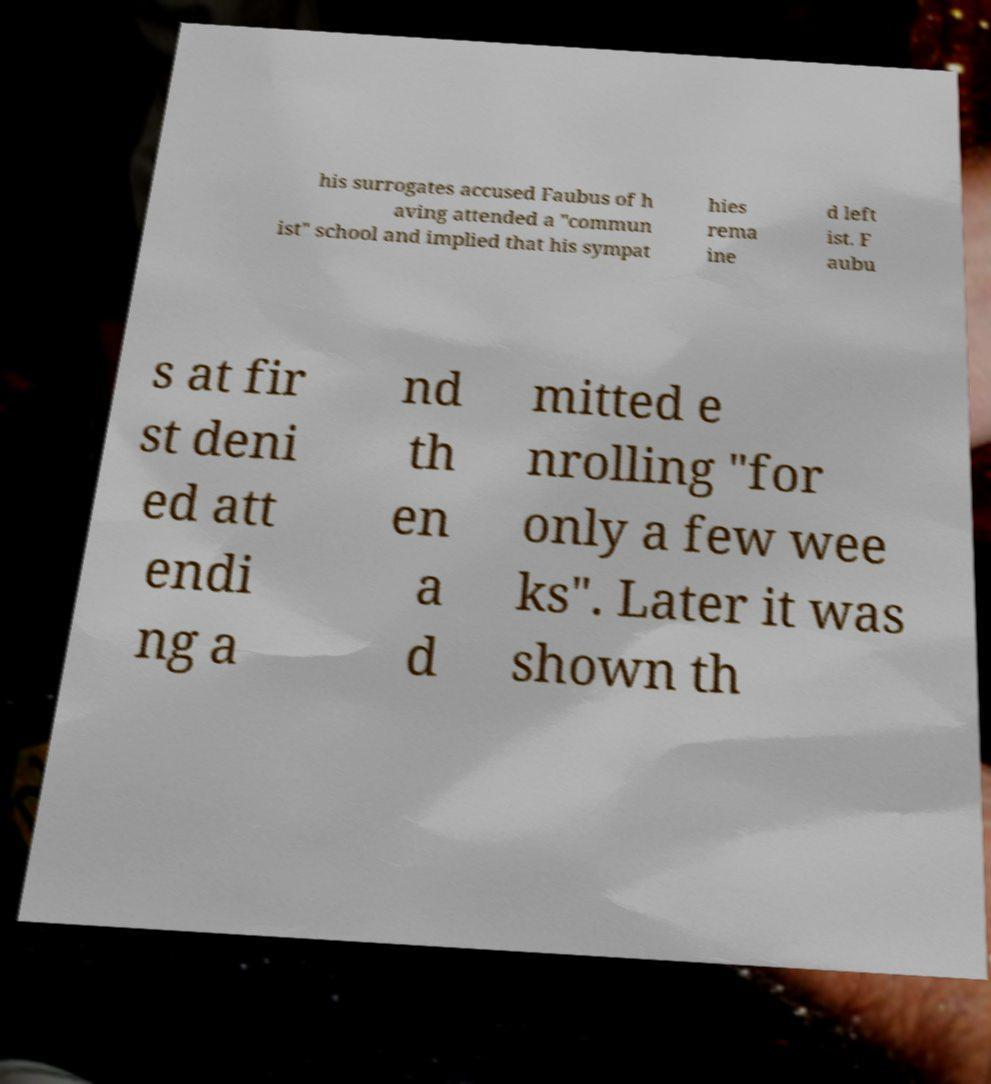Please read and relay the text visible in this image. What does it say? his surrogates accused Faubus of h aving attended a "commun ist" school and implied that his sympat hies rema ine d left ist. F aubu s at fir st deni ed att endi ng a nd th en a d mitted e nrolling "for only a few wee ks". Later it was shown th 